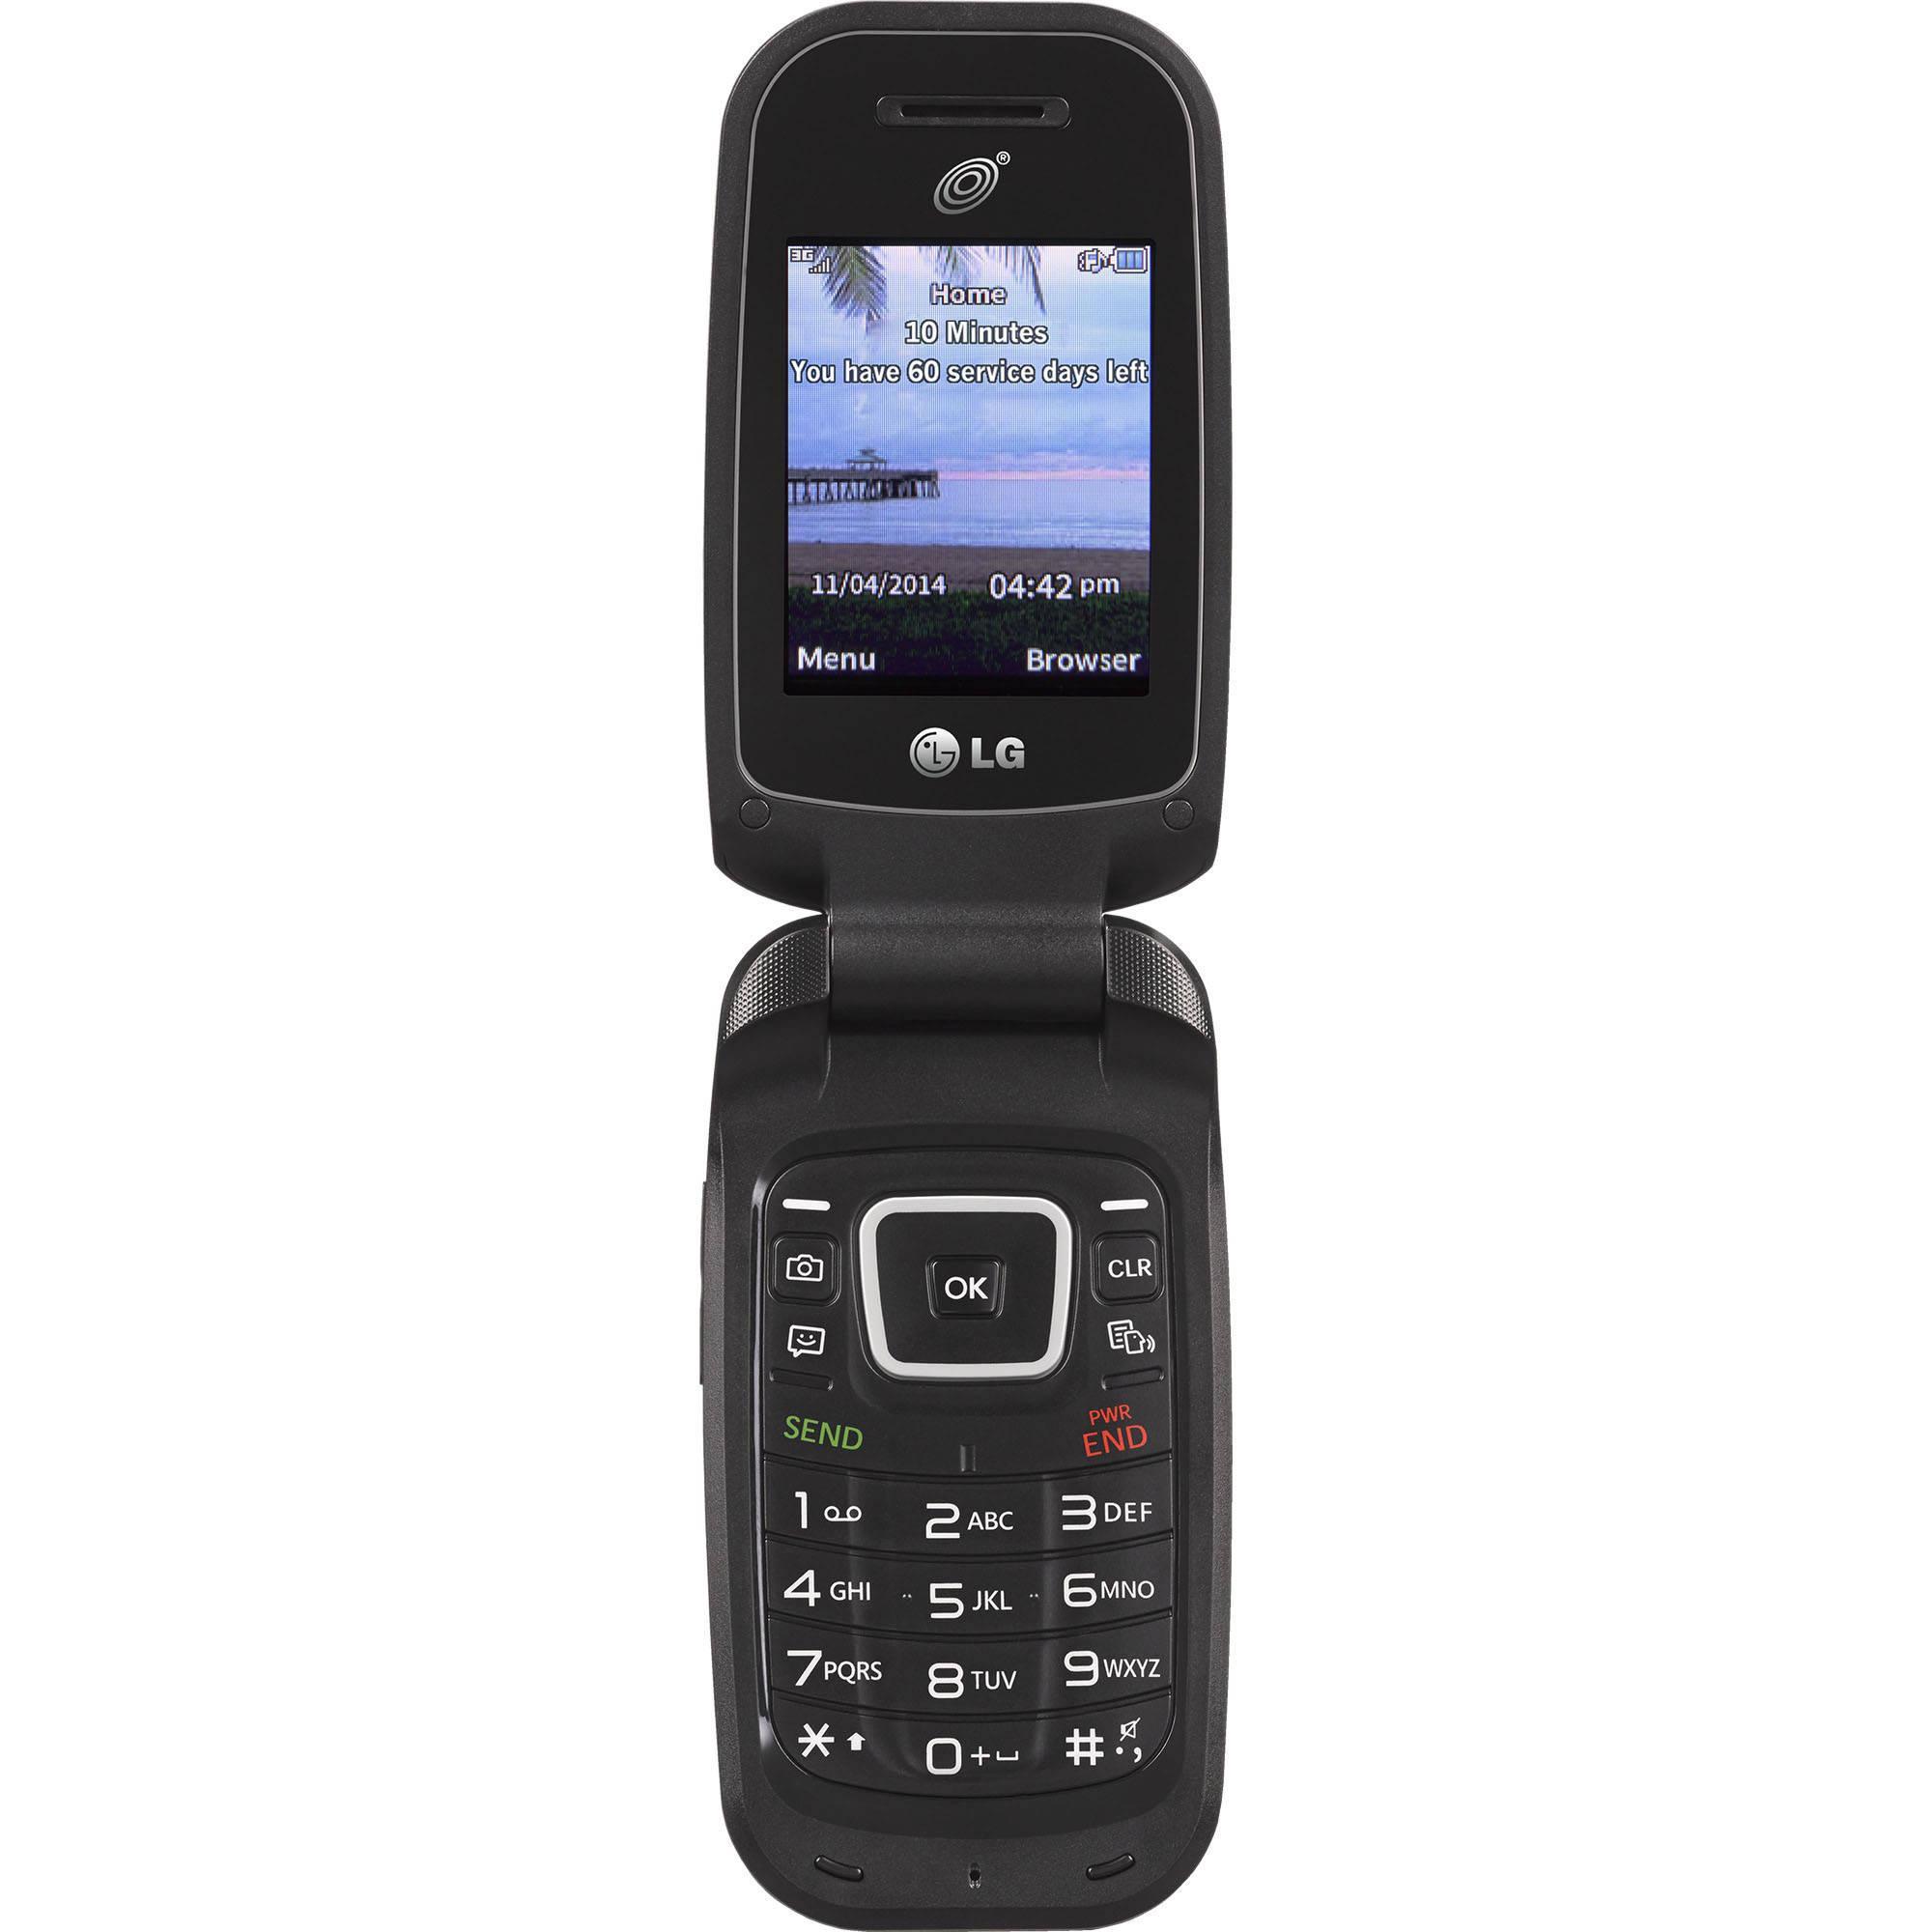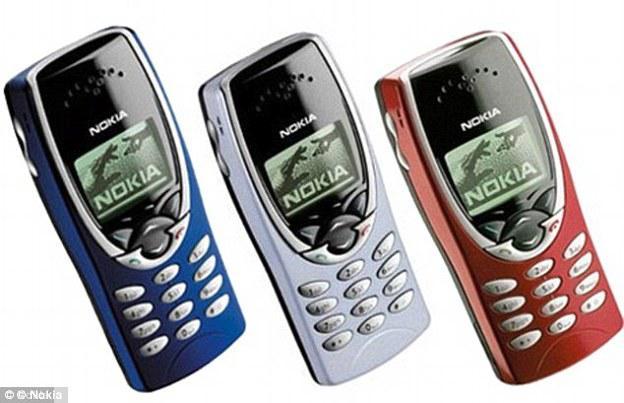The first image is the image on the left, the second image is the image on the right. For the images shown, is this caption "There is a single cell phone in the image on the left and at least twice as many on the right." true? Answer yes or no. Yes. The first image is the image on the left, the second image is the image on the right. For the images shown, is this caption "There is a single phone in the left image." true? Answer yes or no. Yes. 